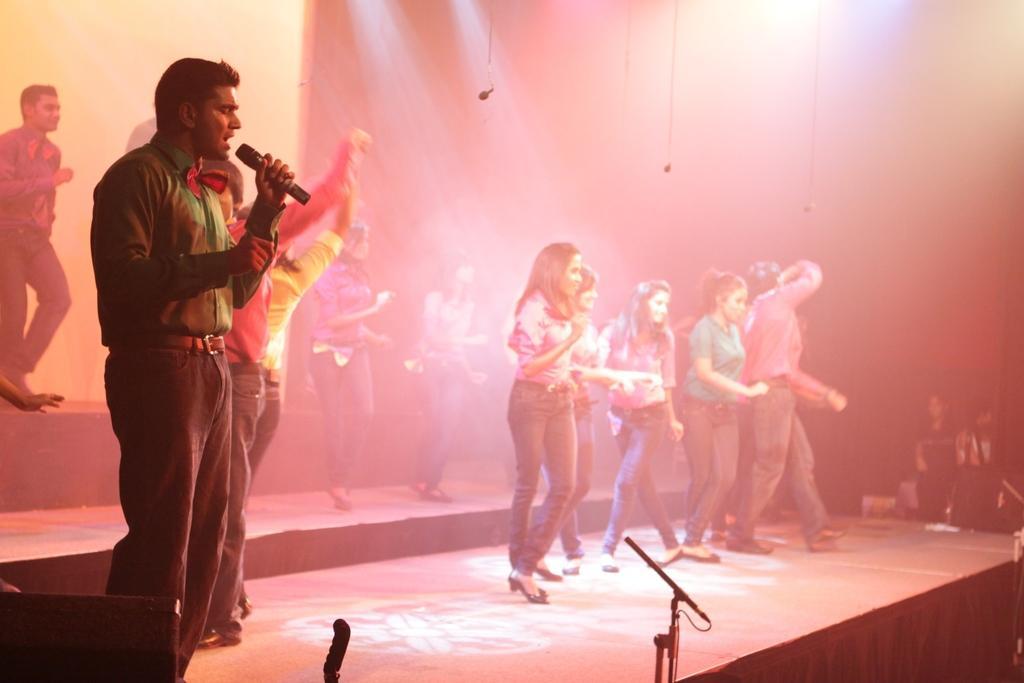Please provide a concise description of this image. In this image we can see group of people standing on the stage. One man wearing green shirt is holding a microphone in his hand. 